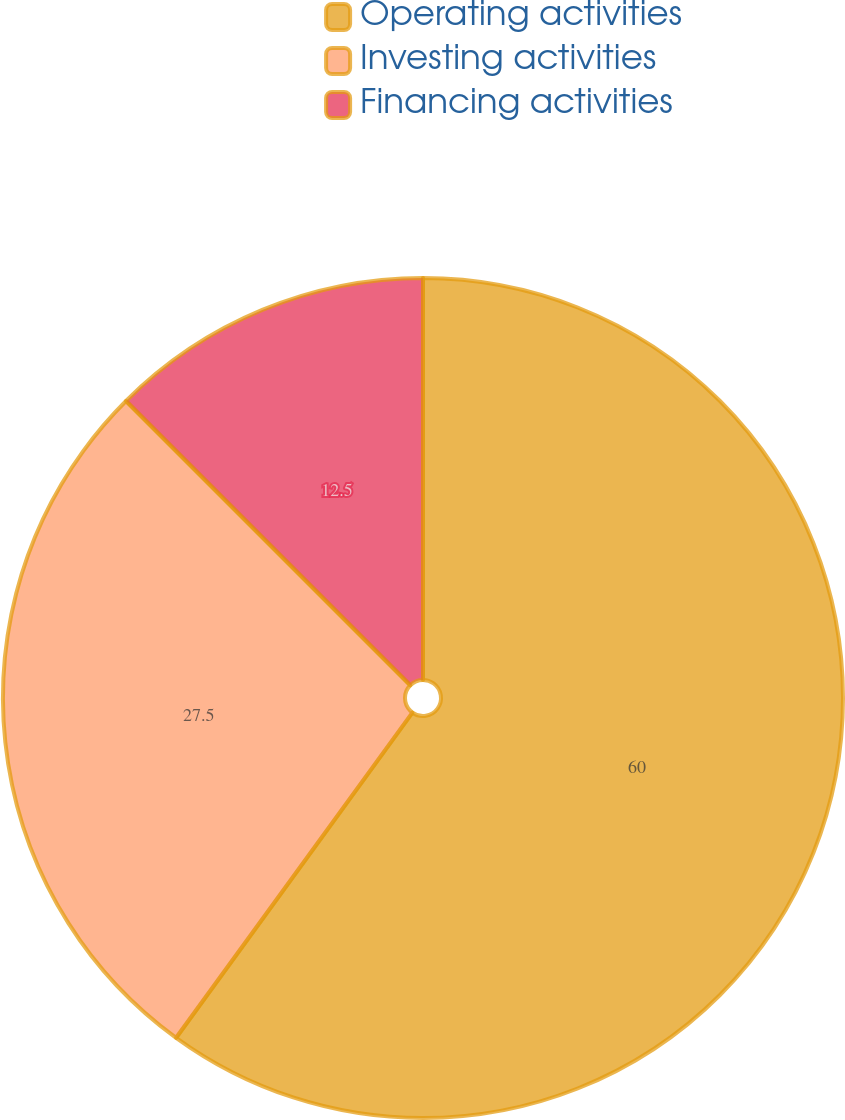<chart> <loc_0><loc_0><loc_500><loc_500><pie_chart><fcel>Operating activities<fcel>Investing activities<fcel>Financing activities<nl><fcel>60.0%<fcel>27.5%<fcel>12.5%<nl></chart> 